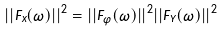<formula> <loc_0><loc_0><loc_500><loc_500>| | F _ { x } ( \omega ) | | ^ { 2 } = | | F _ { \varphi } ( \omega ) | | ^ { 2 } | | F _ { Y } ( \omega ) | | ^ { 2 }</formula> 